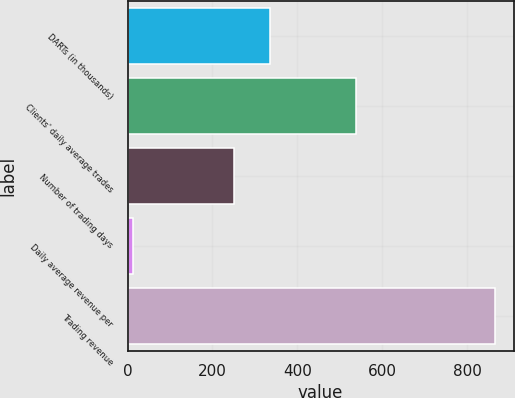Convert chart to OTSL. <chart><loc_0><loc_0><loc_500><loc_500><bar_chart><fcel>DARTs (in thousands)<fcel>Clients' daily average trades<fcel>Number of trading days<fcel>Daily average revenue per<fcel>Trading revenue<nl><fcel>336.42<fcel>536.9<fcel>251<fcel>11.83<fcel>866<nl></chart> 